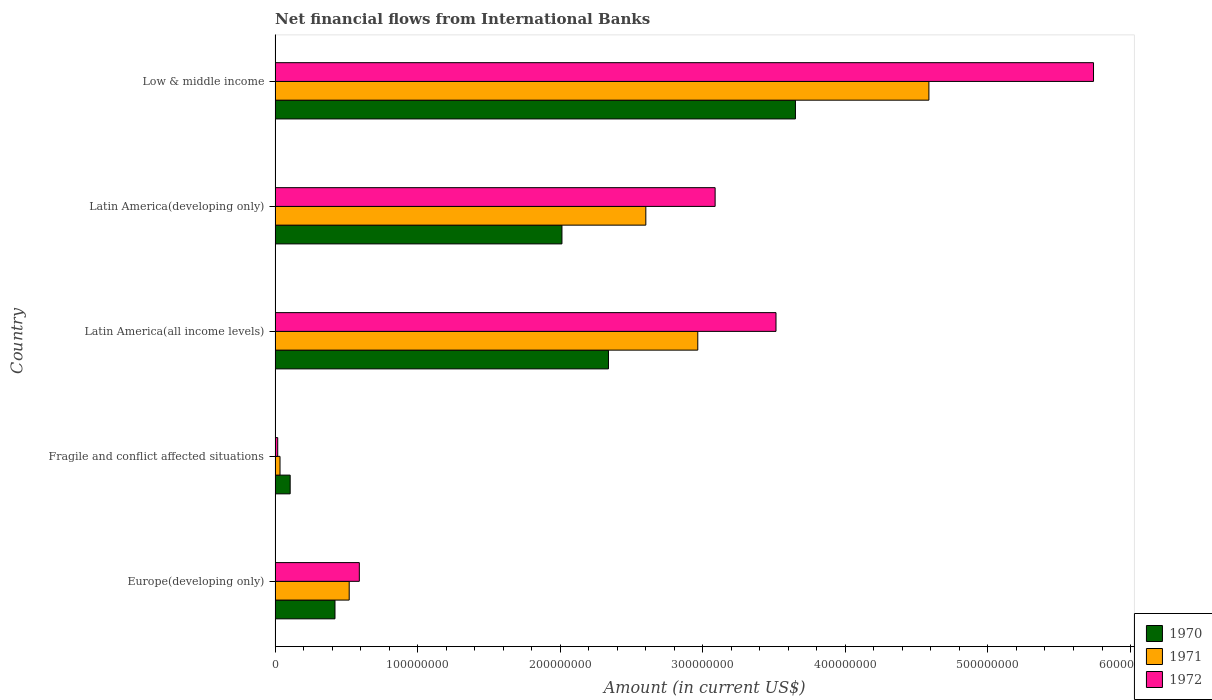How many different coloured bars are there?
Provide a short and direct response. 3. What is the label of the 5th group of bars from the top?
Give a very brief answer. Europe(developing only). In how many cases, is the number of bars for a given country not equal to the number of legend labels?
Your answer should be compact. 0. What is the net financial aid flows in 1972 in Fragile and conflict affected situations?
Offer a terse response. 1.85e+06. Across all countries, what is the maximum net financial aid flows in 1970?
Give a very brief answer. 3.65e+08. Across all countries, what is the minimum net financial aid flows in 1970?
Give a very brief answer. 1.06e+07. In which country was the net financial aid flows in 1972 maximum?
Offer a terse response. Low & middle income. In which country was the net financial aid flows in 1970 minimum?
Ensure brevity in your answer.  Fragile and conflict affected situations. What is the total net financial aid flows in 1971 in the graph?
Offer a very short reply. 1.07e+09. What is the difference between the net financial aid flows in 1971 in Latin America(all income levels) and that in Latin America(developing only)?
Make the answer very short. 3.64e+07. What is the difference between the net financial aid flows in 1971 in Europe(developing only) and the net financial aid flows in 1970 in Fragile and conflict affected situations?
Your answer should be very brief. 4.14e+07. What is the average net financial aid flows in 1971 per country?
Your response must be concise. 2.14e+08. What is the difference between the net financial aid flows in 1972 and net financial aid flows in 1970 in Low & middle income?
Offer a terse response. 2.09e+08. What is the ratio of the net financial aid flows in 1972 in Latin America(all income levels) to that in Latin America(developing only)?
Provide a succinct answer. 1.14. Is the difference between the net financial aid flows in 1972 in Europe(developing only) and Low & middle income greater than the difference between the net financial aid flows in 1970 in Europe(developing only) and Low & middle income?
Offer a very short reply. No. What is the difference between the highest and the second highest net financial aid flows in 1971?
Keep it short and to the point. 1.62e+08. What is the difference between the highest and the lowest net financial aid flows in 1970?
Ensure brevity in your answer.  3.54e+08. Is the sum of the net financial aid flows in 1971 in Latin America(all income levels) and Low & middle income greater than the maximum net financial aid flows in 1970 across all countries?
Your response must be concise. Yes. Where does the legend appear in the graph?
Your answer should be very brief. Bottom right. How many legend labels are there?
Offer a very short reply. 3. How are the legend labels stacked?
Keep it short and to the point. Vertical. What is the title of the graph?
Keep it short and to the point. Net financial flows from International Banks. What is the label or title of the Y-axis?
Ensure brevity in your answer.  Country. What is the Amount (in current US$) of 1970 in Europe(developing only)?
Provide a succinct answer. 4.20e+07. What is the Amount (in current US$) of 1971 in Europe(developing only)?
Keep it short and to the point. 5.20e+07. What is the Amount (in current US$) of 1972 in Europe(developing only)?
Make the answer very short. 5.91e+07. What is the Amount (in current US$) of 1970 in Fragile and conflict affected situations?
Make the answer very short. 1.06e+07. What is the Amount (in current US$) of 1971 in Fragile and conflict affected situations?
Offer a very short reply. 3.47e+06. What is the Amount (in current US$) of 1972 in Fragile and conflict affected situations?
Offer a terse response. 1.85e+06. What is the Amount (in current US$) in 1970 in Latin America(all income levels)?
Offer a very short reply. 2.34e+08. What is the Amount (in current US$) in 1971 in Latin America(all income levels)?
Make the answer very short. 2.96e+08. What is the Amount (in current US$) of 1972 in Latin America(all income levels)?
Provide a short and direct response. 3.51e+08. What is the Amount (in current US$) in 1970 in Latin America(developing only)?
Ensure brevity in your answer.  2.01e+08. What is the Amount (in current US$) in 1971 in Latin America(developing only)?
Offer a terse response. 2.60e+08. What is the Amount (in current US$) in 1972 in Latin America(developing only)?
Ensure brevity in your answer.  3.09e+08. What is the Amount (in current US$) of 1970 in Low & middle income?
Offer a terse response. 3.65e+08. What is the Amount (in current US$) in 1971 in Low & middle income?
Ensure brevity in your answer.  4.59e+08. What is the Amount (in current US$) in 1972 in Low & middle income?
Your answer should be compact. 5.74e+08. Across all countries, what is the maximum Amount (in current US$) of 1970?
Your response must be concise. 3.65e+08. Across all countries, what is the maximum Amount (in current US$) of 1971?
Provide a succinct answer. 4.59e+08. Across all countries, what is the maximum Amount (in current US$) in 1972?
Keep it short and to the point. 5.74e+08. Across all countries, what is the minimum Amount (in current US$) in 1970?
Make the answer very short. 1.06e+07. Across all countries, what is the minimum Amount (in current US$) in 1971?
Your answer should be compact. 3.47e+06. Across all countries, what is the minimum Amount (in current US$) of 1972?
Your response must be concise. 1.85e+06. What is the total Amount (in current US$) in 1970 in the graph?
Your answer should be very brief. 8.53e+08. What is the total Amount (in current US$) in 1971 in the graph?
Offer a very short reply. 1.07e+09. What is the total Amount (in current US$) of 1972 in the graph?
Make the answer very short. 1.29e+09. What is the difference between the Amount (in current US$) in 1970 in Europe(developing only) and that in Fragile and conflict affected situations?
Make the answer very short. 3.14e+07. What is the difference between the Amount (in current US$) in 1971 in Europe(developing only) and that in Fragile and conflict affected situations?
Keep it short and to the point. 4.85e+07. What is the difference between the Amount (in current US$) of 1972 in Europe(developing only) and that in Fragile and conflict affected situations?
Your answer should be compact. 5.72e+07. What is the difference between the Amount (in current US$) in 1970 in Europe(developing only) and that in Latin America(all income levels)?
Your answer should be very brief. -1.92e+08. What is the difference between the Amount (in current US$) in 1971 in Europe(developing only) and that in Latin America(all income levels)?
Give a very brief answer. -2.44e+08. What is the difference between the Amount (in current US$) in 1972 in Europe(developing only) and that in Latin America(all income levels)?
Keep it short and to the point. -2.92e+08. What is the difference between the Amount (in current US$) in 1970 in Europe(developing only) and that in Latin America(developing only)?
Offer a terse response. -1.59e+08. What is the difference between the Amount (in current US$) in 1971 in Europe(developing only) and that in Latin America(developing only)?
Offer a terse response. -2.08e+08. What is the difference between the Amount (in current US$) of 1972 in Europe(developing only) and that in Latin America(developing only)?
Provide a short and direct response. -2.50e+08. What is the difference between the Amount (in current US$) of 1970 in Europe(developing only) and that in Low & middle income?
Offer a very short reply. -3.23e+08. What is the difference between the Amount (in current US$) of 1971 in Europe(developing only) and that in Low & middle income?
Your response must be concise. -4.07e+08. What is the difference between the Amount (in current US$) of 1972 in Europe(developing only) and that in Low & middle income?
Offer a very short reply. -5.15e+08. What is the difference between the Amount (in current US$) in 1970 in Fragile and conflict affected situations and that in Latin America(all income levels)?
Your answer should be compact. -2.23e+08. What is the difference between the Amount (in current US$) of 1971 in Fragile and conflict affected situations and that in Latin America(all income levels)?
Give a very brief answer. -2.93e+08. What is the difference between the Amount (in current US$) in 1972 in Fragile and conflict affected situations and that in Latin America(all income levels)?
Keep it short and to the point. -3.49e+08. What is the difference between the Amount (in current US$) in 1970 in Fragile and conflict affected situations and that in Latin America(developing only)?
Give a very brief answer. -1.91e+08. What is the difference between the Amount (in current US$) of 1971 in Fragile and conflict affected situations and that in Latin America(developing only)?
Your answer should be compact. -2.57e+08. What is the difference between the Amount (in current US$) of 1972 in Fragile and conflict affected situations and that in Latin America(developing only)?
Your answer should be compact. -3.07e+08. What is the difference between the Amount (in current US$) of 1970 in Fragile and conflict affected situations and that in Low & middle income?
Your answer should be compact. -3.54e+08. What is the difference between the Amount (in current US$) in 1971 in Fragile and conflict affected situations and that in Low & middle income?
Offer a terse response. -4.55e+08. What is the difference between the Amount (in current US$) of 1972 in Fragile and conflict affected situations and that in Low & middle income?
Provide a short and direct response. -5.72e+08. What is the difference between the Amount (in current US$) of 1970 in Latin America(all income levels) and that in Latin America(developing only)?
Offer a very short reply. 3.26e+07. What is the difference between the Amount (in current US$) in 1971 in Latin America(all income levels) and that in Latin America(developing only)?
Make the answer very short. 3.64e+07. What is the difference between the Amount (in current US$) of 1972 in Latin America(all income levels) and that in Latin America(developing only)?
Offer a very short reply. 4.27e+07. What is the difference between the Amount (in current US$) of 1970 in Latin America(all income levels) and that in Low & middle income?
Your answer should be compact. -1.31e+08. What is the difference between the Amount (in current US$) of 1971 in Latin America(all income levels) and that in Low & middle income?
Give a very brief answer. -1.62e+08. What is the difference between the Amount (in current US$) in 1972 in Latin America(all income levels) and that in Low & middle income?
Provide a succinct answer. -2.23e+08. What is the difference between the Amount (in current US$) in 1970 in Latin America(developing only) and that in Low & middle income?
Make the answer very short. -1.64e+08. What is the difference between the Amount (in current US$) of 1971 in Latin America(developing only) and that in Low & middle income?
Provide a succinct answer. -1.99e+08. What is the difference between the Amount (in current US$) of 1972 in Latin America(developing only) and that in Low & middle income?
Provide a short and direct response. -2.65e+08. What is the difference between the Amount (in current US$) in 1970 in Europe(developing only) and the Amount (in current US$) in 1971 in Fragile and conflict affected situations?
Your answer should be very brief. 3.85e+07. What is the difference between the Amount (in current US$) in 1970 in Europe(developing only) and the Amount (in current US$) in 1972 in Fragile and conflict affected situations?
Ensure brevity in your answer.  4.02e+07. What is the difference between the Amount (in current US$) of 1971 in Europe(developing only) and the Amount (in current US$) of 1972 in Fragile and conflict affected situations?
Your answer should be compact. 5.01e+07. What is the difference between the Amount (in current US$) of 1970 in Europe(developing only) and the Amount (in current US$) of 1971 in Latin America(all income levels)?
Ensure brevity in your answer.  -2.54e+08. What is the difference between the Amount (in current US$) in 1970 in Europe(developing only) and the Amount (in current US$) in 1972 in Latin America(all income levels)?
Make the answer very short. -3.09e+08. What is the difference between the Amount (in current US$) in 1971 in Europe(developing only) and the Amount (in current US$) in 1972 in Latin America(all income levels)?
Make the answer very short. -2.99e+08. What is the difference between the Amount (in current US$) of 1970 in Europe(developing only) and the Amount (in current US$) of 1971 in Latin America(developing only)?
Provide a short and direct response. -2.18e+08. What is the difference between the Amount (in current US$) of 1970 in Europe(developing only) and the Amount (in current US$) of 1972 in Latin America(developing only)?
Ensure brevity in your answer.  -2.67e+08. What is the difference between the Amount (in current US$) in 1971 in Europe(developing only) and the Amount (in current US$) in 1972 in Latin America(developing only)?
Offer a very short reply. -2.57e+08. What is the difference between the Amount (in current US$) in 1970 in Europe(developing only) and the Amount (in current US$) in 1971 in Low & middle income?
Make the answer very short. -4.17e+08. What is the difference between the Amount (in current US$) in 1970 in Europe(developing only) and the Amount (in current US$) in 1972 in Low & middle income?
Give a very brief answer. -5.32e+08. What is the difference between the Amount (in current US$) of 1971 in Europe(developing only) and the Amount (in current US$) of 1972 in Low & middle income?
Your response must be concise. -5.22e+08. What is the difference between the Amount (in current US$) in 1970 in Fragile and conflict affected situations and the Amount (in current US$) in 1971 in Latin America(all income levels)?
Your answer should be compact. -2.86e+08. What is the difference between the Amount (in current US$) of 1970 in Fragile and conflict affected situations and the Amount (in current US$) of 1972 in Latin America(all income levels)?
Your answer should be compact. -3.41e+08. What is the difference between the Amount (in current US$) of 1971 in Fragile and conflict affected situations and the Amount (in current US$) of 1972 in Latin America(all income levels)?
Offer a very short reply. -3.48e+08. What is the difference between the Amount (in current US$) in 1970 in Fragile and conflict affected situations and the Amount (in current US$) in 1971 in Latin America(developing only)?
Provide a short and direct response. -2.49e+08. What is the difference between the Amount (in current US$) of 1970 in Fragile and conflict affected situations and the Amount (in current US$) of 1972 in Latin America(developing only)?
Provide a short and direct response. -2.98e+08. What is the difference between the Amount (in current US$) in 1971 in Fragile and conflict affected situations and the Amount (in current US$) in 1972 in Latin America(developing only)?
Provide a short and direct response. -3.05e+08. What is the difference between the Amount (in current US$) in 1970 in Fragile and conflict affected situations and the Amount (in current US$) in 1971 in Low & middle income?
Give a very brief answer. -4.48e+08. What is the difference between the Amount (in current US$) of 1970 in Fragile and conflict affected situations and the Amount (in current US$) of 1972 in Low & middle income?
Give a very brief answer. -5.63e+08. What is the difference between the Amount (in current US$) of 1971 in Fragile and conflict affected situations and the Amount (in current US$) of 1972 in Low & middle income?
Keep it short and to the point. -5.71e+08. What is the difference between the Amount (in current US$) in 1970 in Latin America(all income levels) and the Amount (in current US$) in 1971 in Latin America(developing only)?
Make the answer very short. -2.62e+07. What is the difference between the Amount (in current US$) in 1970 in Latin America(all income levels) and the Amount (in current US$) in 1972 in Latin America(developing only)?
Make the answer very short. -7.48e+07. What is the difference between the Amount (in current US$) in 1971 in Latin America(all income levels) and the Amount (in current US$) in 1972 in Latin America(developing only)?
Give a very brief answer. -1.22e+07. What is the difference between the Amount (in current US$) in 1970 in Latin America(all income levels) and the Amount (in current US$) in 1971 in Low & middle income?
Your response must be concise. -2.25e+08. What is the difference between the Amount (in current US$) in 1970 in Latin America(all income levels) and the Amount (in current US$) in 1972 in Low & middle income?
Give a very brief answer. -3.40e+08. What is the difference between the Amount (in current US$) of 1971 in Latin America(all income levels) and the Amount (in current US$) of 1972 in Low & middle income?
Offer a terse response. -2.78e+08. What is the difference between the Amount (in current US$) in 1970 in Latin America(developing only) and the Amount (in current US$) in 1971 in Low & middle income?
Ensure brevity in your answer.  -2.57e+08. What is the difference between the Amount (in current US$) of 1970 in Latin America(developing only) and the Amount (in current US$) of 1972 in Low & middle income?
Provide a succinct answer. -3.73e+08. What is the difference between the Amount (in current US$) of 1971 in Latin America(developing only) and the Amount (in current US$) of 1972 in Low & middle income?
Keep it short and to the point. -3.14e+08. What is the average Amount (in current US$) in 1970 per country?
Provide a short and direct response. 1.71e+08. What is the average Amount (in current US$) of 1971 per country?
Your answer should be very brief. 2.14e+08. What is the average Amount (in current US$) in 1972 per country?
Keep it short and to the point. 2.59e+08. What is the difference between the Amount (in current US$) of 1970 and Amount (in current US$) of 1971 in Europe(developing only)?
Ensure brevity in your answer.  -9.98e+06. What is the difference between the Amount (in current US$) of 1970 and Amount (in current US$) of 1972 in Europe(developing only)?
Provide a succinct answer. -1.71e+07. What is the difference between the Amount (in current US$) in 1971 and Amount (in current US$) in 1972 in Europe(developing only)?
Provide a short and direct response. -7.10e+06. What is the difference between the Amount (in current US$) of 1970 and Amount (in current US$) of 1971 in Fragile and conflict affected situations?
Make the answer very short. 7.12e+06. What is the difference between the Amount (in current US$) in 1970 and Amount (in current US$) in 1972 in Fragile and conflict affected situations?
Your answer should be compact. 8.74e+06. What is the difference between the Amount (in current US$) of 1971 and Amount (in current US$) of 1972 in Fragile and conflict affected situations?
Give a very brief answer. 1.62e+06. What is the difference between the Amount (in current US$) in 1970 and Amount (in current US$) in 1971 in Latin America(all income levels)?
Keep it short and to the point. -6.26e+07. What is the difference between the Amount (in current US$) of 1970 and Amount (in current US$) of 1972 in Latin America(all income levels)?
Make the answer very short. -1.18e+08. What is the difference between the Amount (in current US$) of 1971 and Amount (in current US$) of 1972 in Latin America(all income levels)?
Provide a succinct answer. -5.49e+07. What is the difference between the Amount (in current US$) of 1970 and Amount (in current US$) of 1971 in Latin America(developing only)?
Provide a succinct answer. -5.88e+07. What is the difference between the Amount (in current US$) in 1970 and Amount (in current US$) in 1972 in Latin America(developing only)?
Offer a very short reply. -1.07e+08. What is the difference between the Amount (in current US$) of 1971 and Amount (in current US$) of 1972 in Latin America(developing only)?
Your response must be concise. -4.86e+07. What is the difference between the Amount (in current US$) of 1970 and Amount (in current US$) of 1971 in Low & middle income?
Make the answer very short. -9.36e+07. What is the difference between the Amount (in current US$) in 1970 and Amount (in current US$) in 1972 in Low & middle income?
Your answer should be compact. -2.09e+08. What is the difference between the Amount (in current US$) of 1971 and Amount (in current US$) of 1972 in Low & middle income?
Offer a very short reply. -1.15e+08. What is the ratio of the Amount (in current US$) in 1970 in Europe(developing only) to that in Fragile and conflict affected situations?
Give a very brief answer. 3.97. What is the ratio of the Amount (in current US$) in 1971 in Europe(developing only) to that in Fragile and conflict affected situations?
Make the answer very short. 15. What is the ratio of the Amount (in current US$) in 1972 in Europe(developing only) to that in Fragile and conflict affected situations?
Your response must be concise. 31.98. What is the ratio of the Amount (in current US$) in 1970 in Europe(developing only) to that in Latin America(all income levels)?
Your response must be concise. 0.18. What is the ratio of the Amount (in current US$) in 1971 in Europe(developing only) to that in Latin America(all income levels)?
Your answer should be compact. 0.18. What is the ratio of the Amount (in current US$) of 1972 in Europe(developing only) to that in Latin America(all income levels)?
Keep it short and to the point. 0.17. What is the ratio of the Amount (in current US$) of 1970 in Europe(developing only) to that in Latin America(developing only)?
Your answer should be compact. 0.21. What is the ratio of the Amount (in current US$) of 1971 in Europe(developing only) to that in Latin America(developing only)?
Make the answer very short. 0.2. What is the ratio of the Amount (in current US$) of 1972 in Europe(developing only) to that in Latin America(developing only)?
Your response must be concise. 0.19. What is the ratio of the Amount (in current US$) in 1970 in Europe(developing only) to that in Low & middle income?
Provide a short and direct response. 0.12. What is the ratio of the Amount (in current US$) in 1971 in Europe(developing only) to that in Low & middle income?
Offer a terse response. 0.11. What is the ratio of the Amount (in current US$) in 1972 in Europe(developing only) to that in Low & middle income?
Your answer should be compact. 0.1. What is the ratio of the Amount (in current US$) in 1970 in Fragile and conflict affected situations to that in Latin America(all income levels)?
Your answer should be compact. 0.05. What is the ratio of the Amount (in current US$) in 1971 in Fragile and conflict affected situations to that in Latin America(all income levels)?
Offer a very short reply. 0.01. What is the ratio of the Amount (in current US$) in 1972 in Fragile and conflict affected situations to that in Latin America(all income levels)?
Your response must be concise. 0.01. What is the ratio of the Amount (in current US$) in 1970 in Fragile and conflict affected situations to that in Latin America(developing only)?
Give a very brief answer. 0.05. What is the ratio of the Amount (in current US$) of 1971 in Fragile and conflict affected situations to that in Latin America(developing only)?
Keep it short and to the point. 0.01. What is the ratio of the Amount (in current US$) of 1972 in Fragile and conflict affected situations to that in Latin America(developing only)?
Provide a short and direct response. 0.01. What is the ratio of the Amount (in current US$) of 1970 in Fragile and conflict affected situations to that in Low & middle income?
Your response must be concise. 0.03. What is the ratio of the Amount (in current US$) in 1971 in Fragile and conflict affected situations to that in Low & middle income?
Offer a very short reply. 0.01. What is the ratio of the Amount (in current US$) of 1972 in Fragile and conflict affected situations to that in Low & middle income?
Provide a short and direct response. 0. What is the ratio of the Amount (in current US$) in 1970 in Latin America(all income levels) to that in Latin America(developing only)?
Your answer should be compact. 1.16. What is the ratio of the Amount (in current US$) of 1971 in Latin America(all income levels) to that in Latin America(developing only)?
Ensure brevity in your answer.  1.14. What is the ratio of the Amount (in current US$) in 1972 in Latin America(all income levels) to that in Latin America(developing only)?
Provide a succinct answer. 1.14. What is the ratio of the Amount (in current US$) of 1970 in Latin America(all income levels) to that in Low & middle income?
Provide a short and direct response. 0.64. What is the ratio of the Amount (in current US$) of 1971 in Latin America(all income levels) to that in Low & middle income?
Keep it short and to the point. 0.65. What is the ratio of the Amount (in current US$) in 1972 in Latin America(all income levels) to that in Low & middle income?
Ensure brevity in your answer.  0.61. What is the ratio of the Amount (in current US$) of 1970 in Latin America(developing only) to that in Low & middle income?
Offer a very short reply. 0.55. What is the ratio of the Amount (in current US$) of 1971 in Latin America(developing only) to that in Low & middle income?
Keep it short and to the point. 0.57. What is the ratio of the Amount (in current US$) in 1972 in Latin America(developing only) to that in Low & middle income?
Ensure brevity in your answer.  0.54. What is the difference between the highest and the second highest Amount (in current US$) of 1970?
Give a very brief answer. 1.31e+08. What is the difference between the highest and the second highest Amount (in current US$) of 1971?
Offer a terse response. 1.62e+08. What is the difference between the highest and the second highest Amount (in current US$) in 1972?
Your answer should be compact. 2.23e+08. What is the difference between the highest and the lowest Amount (in current US$) of 1970?
Your answer should be compact. 3.54e+08. What is the difference between the highest and the lowest Amount (in current US$) in 1971?
Keep it short and to the point. 4.55e+08. What is the difference between the highest and the lowest Amount (in current US$) of 1972?
Give a very brief answer. 5.72e+08. 